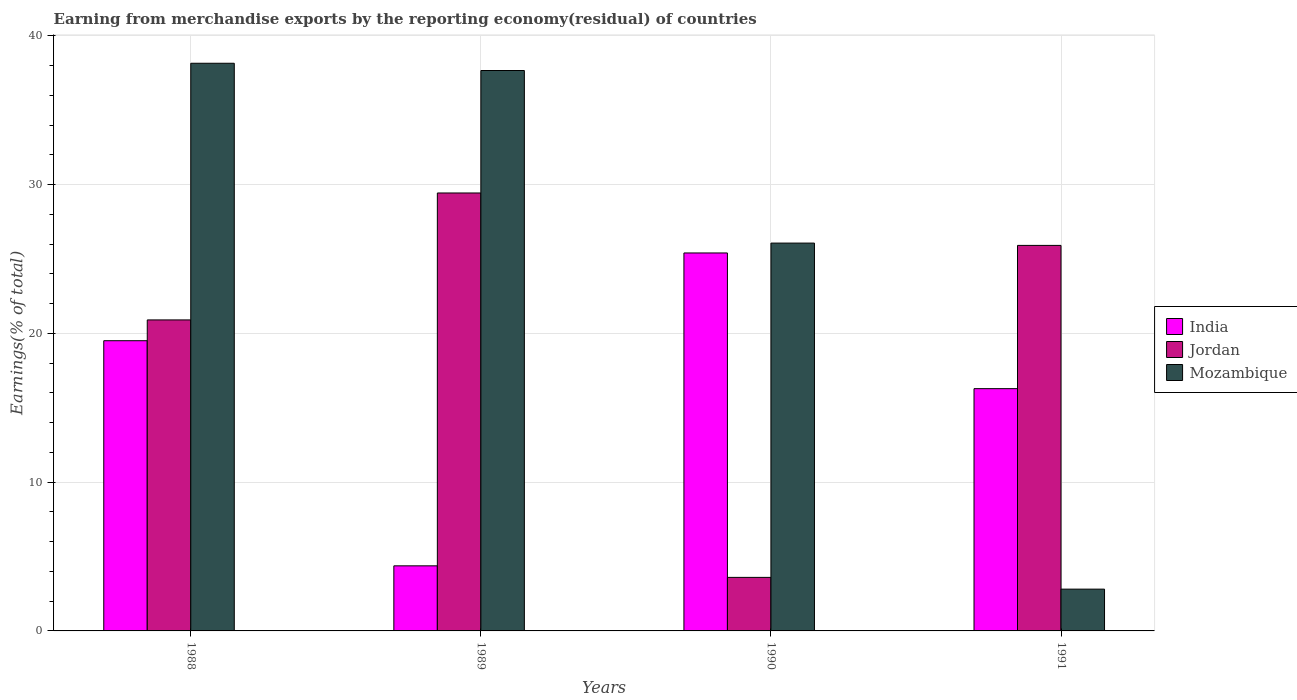How many groups of bars are there?
Ensure brevity in your answer.  4. What is the percentage of amount earned from merchandise exports in Jordan in 1988?
Keep it short and to the point. 20.91. Across all years, what is the maximum percentage of amount earned from merchandise exports in Jordan?
Ensure brevity in your answer.  29.44. Across all years, what is the minimum percentage of amount earned from merchandise exports in Mozambique?
Give a very brief answer. 2.81. In which year was the percentage of amount earned from merchandise exports in Jordan maximum?
Offer a terse response. 1989. In which year was the percentage of amount earned from merchandise exports in Jordan minimum?
Provide a short and direct response. 1990. What is the total percentage of amount earned from merchandise exports in India in the graph?
Make the answer very short. 65.57. What is the difference between the percentage of amount earned from merchandise exports in Jordan in 1988 and that in 1990?
Keep it short and to the point. 17.31. What is the difference between the percentage of amount earned from merchandise exports in Mozambique in 1988 and the percentage of amount earned from merchandise exports in Jordan in 1989?
Your answer should be compact. 8.72. What is the average percentage of amount earned from merchandise exports in India per year?
Your response must be concise. 16.39. In the year 1991, what is the difference between the percentage of amount earned from merchandise exports in Mozambique and percentage of amount earned from merchandise exports in Jordan?
Your answer should be very brief. -23.11. In how many years, is the percentage of amount earned from merchandise exports in India greater than 16 %?
Provide a succinct answer. 3. What is the ratio of the percentage of amount earned from merchandise exports in Mozambique in 1989 to that in 1990?
Your answer should be very brief. 1.44. Is the percentage of amount earned from merchandise exports in Jordan in 1990 less than that in 1991?
Make the answer very short. Yes. Is the difference between the percentage of amount earned from merchandise exports in Mozambique in 1989 and 1990 greater than the difference between the percentage of amount earned from merchandise exports in Jordan in 1989 and 1990?
Your answer should be compact. No. What is the difference between the highest and the second highest percentage of amount earned from merchandise exports in Mozambique?
Make the answer very short. 0.49. What is the difference between the highest and the lowest percentage of amount earned from merchandise exports in Mozambique?
Provide a succinct answer. 35.35. Is the sum of the percentage of amount earned from merchandise exports in India in 1990 and 1991 greater than the maximum percentage of amount earned from merchandise exports in Jordan across all years?
Keep it short and to the point. Yes. What does the 3rd bar from the left in 1990 represents?
Your answer should be very brief. Mozambique. What does the 2nd bar from the right in 1991 represents?
Your answer should be very brief. Jordan. How many legend labels are there?
Make the answer very short. 3. What is the title of the graph?
Provide a short and direct response. Earning from merchandise exports by the reporting economy(residual) of countries. What is the label or title of the X-axis?
Provide a succinct answer. Years. What is the label or title of the Y-axis?
Keep it short and to the point. Earnings(% of total). What is the Earnings(% of total) in India in 1988?
Make the answer very short. 19.51. What is the Earnings(% of total) of Jordan in 1988?
Offer a terse response. 20.91. What is the Earnings(% of total) in Mozambique in 1988?
Your answer should be very brief. 38.16. What is the Earnings(% of total) in India in 1989?
Keep it short and to the point. 4.37. What is the Earnings(% of total) of Jordan in 1989?
Offer a very short reply. 29.44. What is the Earnings(% of total) of Mozambique in 1989?
Your answer should be very brief. 37.67. What is the Earnings(% of total) of India in 1990?
Ensure brevity in your answer.  25.41. What is the Earnings(% of total) of Jordan in 1990?
Your response must be concise. 3.6. What is the Earnings(% of total) in Mozambique in 1990?
Provide a short and direct response. 26.07. What is the Earnings(% of total) of India in 1991?
Provide a short and direct response. 16.28. What is the Earnings(% of total) in Jordan in 1991?
Offer a very short reply. 25.91. What is the Earnings(% of total) of Mozambique in 1991?
Ensure brevity in your answer.  2.81. Across all years, what is the maximum Earnings(% of total) in India?
Your response must be concise. 25.41. Across all years, what is the maximum Earnings(% of total) of Jordan?
Offer a very short reply. 29.44. Across all years, what is the maximum Earnings(% of total) in Mozambique?
Give a very brief answer. 38.16. Across all years, what is the minimum Earnings(% of total) in India?
Give a very brief answer. 4.37. Across all years, what is the minimum Earnings(% of total) in Jordan?
Ensure brevity in your answer.  3.6. Across all years, what is the minimum Earnings(% of total) of Mozambique?
Provide a short and direct response. 2.81. What is the total Earnings(% of total) of India in the graph?
Provide a short and direct response. 65.57. What is the total Earnings(% of total) of Jordan in the graph?
Provide a short and direct response. 79.86. What is the total Earnings(% of total) of Mozambique in the graph?
Keep it short and to the point. 104.71. What is the difference between the Earnings(% of total) in India in 1988 and that in 1989?
Your response must be concise. 15.13. What is the difference between the Earnings(% of total) of Jordan in 1988 and that in 1989?
Provide a succinct answer. -8.53. What is the difference between the Earnings(% of total) in Mozambique in 1988 and that in 1989?
Give a very brief answer. 0.49. What is the difference between the Earnings(% of total) of India in 1988 and that in 1990?
Provide a succinct answer. -5.9. What is the difference between the Earnings(% of total) of Jordan in 1988 and that in 1990?
Give a very brief answer. 17.31. What is the difference between the Earnings(% of total) of Mozambique in 1988 and that in 1990?
Keep it short and to the point. 12.09. What is the difference between the Earnings(% of total) in India in 1988 and that in 1991?
Your answer should be compact. 3.22. What is the difference between the Earnings(% of total) of Jordan in 1988 and that in 1991?
Make the answer very short. -5.01. What is the difference between the Earnings(% of total) in Mozambique in 1988 and that in 1991?
Offer a very short reply. 35.35. What is the difference between the Earnings(% of total) in India in 1989 and that in 1990?
Provide a short and direct response. -21.03. What is the difference between the Earnings(% of total) of Jordan in 1989 and that in 1990?
Your response must be concise. 25.84. What is the difference between the Earnings(% of total) in Mozambique in 1989 and that in 1990?
Ensure brevity in your answer.  11.6. What is the difference between the Earnings(% of total) of India in 1989 and that in 1991?
Offer a terse response. -11.91. What is the difference between the Earnings(% of total) in Jordan in 1989 and that in 1991?
Offer a terse response. 3.52. What is the difference between the Earnings(% of total) in Mozambique in 1989 and that in 1991?
Your answer should be compact. 34.86. What is the difference between the Earnings(% of total) in India in 1990 and that in 1991?
Your answer should be compact. 9.12. What is the difference between the Earnings(% of total) in Jordan in 1990 and that in 1991?
Your answer should be compact. -22.32. What is the difference between the Earnings(% of total) of Mozambique in 1990 and that in 1991?
Ensure brevity in your answer.  23.26. What is the difference between the Earnings(% of total) of India in 1988 and the Earnings(% of total) of Jordan in 1989?
Provide a succinct answer. -9.93. What is the difference between the Earnings(% of total) of India in 1988 and the Earnings(% of total) of Mozambique in 1989?
Provide a succinct answer. -18.16. What is the difference between the Earnings(% of total) in Jordan in 1988 and the Earnings(% of total) in Mozambique in 1989?
Keep it short and to the point. -16.77. What is the difference between the Earnings(% of total) of India in 1988 and the Earnings(% of total) of Jordan in 1990?
Ensure brevity in your answer.  15.91. What is the difference between the Earnings(% of total) in India in 1988 and the Earnings(% of total) in Mozambique in 1990?
Provide a short and direct response. -6.56. What is the difference between the Earnings(% of total) in Jordan in 1988 and the Earnings(% of total) in Mozambique in 1990?
Offer a very short reply. -5.16. What is the difference between the Earnings(% of total) of India in 1988 and the Earnings(% of total) of Jordan in 1991?
Your answer should be compact. -6.41. What is the difference between the Earnings(% of total) of India in 1988 and the Earnings(% of total) of Mozambique in 1991?
Your answer should be compact. 16.7. What is the difference between the Earnings(% of total) in Jordan in 1988 and the Earnings(% of total) in Mozambique in 1991?
Provide a succinct answer. 18.1. What is the difference between the Earnings(% of total) in India in 1989 and the Earnings(% of total) in Jordan in 1990?
Give a very brief answer. 0.78. What is the difference between the Earnings(% of total) of India in 1989 and the Earnings(% of total) of Mozambique in 1990?
Offer a very short reply. -21.69. What is the difference between the Earnings(% of total) in Jordan in 1989 and the Earnings(% of total) in Mozambique in 1990?
Ensure brevity in your answer.  3.37. What is the difference between the Earnings(% of total) in India in 1989 and the Earnings(% of total) in Jordan in 1991?
Your answer should be compact. -21.54. What is the difference between the Earnings(% of total) of India in 1989 and the Earnings(% of total) of Mozambique in 1991?
Ensure brevity in your answer.  1.57. What is the difference between the Earnings(% of total) of Jordan in 1989 and the Earnings(% of total) of Mozambique in 1991?
Your answer should be compact. 26.63. What is the difference between the Earnings(% of total) of India in 1990 and the Earnings(% of total) of Jordan in 1991?
Your answer should be compact. -0.51. What is the difference between the Earnings(% of total) in India in 1990 and the Earnings(% of total) in Mozambique in 1991?
Make the answer very short. 22.6. What is the difference between the Earnings(% of total) in Jordan in 1990 and the Earnings(% of total) in Mozambique in 1991?
Your response must be concise. 0.79. What is the average Earnings(% of total) of India per year?
Provide a succinct answer. 16.39. What is the average Earnings(% of total) in Jordan per year?
Make the answer very short. 19.96. What is the average Earnings(% of total) of Mozambique per year?
Offer a very short reply. 26.18. In the year 1988, what is the difference between the Earnings(% of total) in India and Earnings(% of total) in Jordan?
Make the answer very short. -1.4. In the year 1988, what is the difference between the Earnings(% of total) of India and Earnings(% of total) of Mozambique?
Offer a terse response. -18.65. In the year 1988, what is the difference between the Earnings(% of total) of Jordan and Earnings(% of total) of Mozambique?
Keep it short and to the point. -17.25. In the year 1989, what is the difference between the Earnings(% of total) in India and Earnings(% of total) in Jordan?
Ensure brevity in your answer.  -25.06. In the year 1989, what is the difference between the Earnings(% of total) in India and Earnings(% of total) in Mozambique?
Your answer should be very brief. -33.3. In the year 1989, what is the difference between the Earnings(% of total) in Jordan and Earnings(% of total) in Mozambique?
Offer a very short reply. -8.23. In the year 1990, what is the difference between the Earnings(% of total) in India and Earnings(% of total) in Jordan?
Offer a very short reply. 21.81. In the year 1990, what is the difference between the Earnings(% of total) of India and Earnings(% of total) of Mozambique?
Your answer should be compact. -0.66. In the year 1990, what is the difference between the Earnings(% of total) of Jordan and Earnings(% of total) of Mozambique?
Give a very brief answer. -22.47. In the year 1991, what is the difference between the Earnings(% of total) of India and Earnings(% of total) of Jordan?
Offer a terse response. -9.63. In the year 1991, what is the difference between the Earnings(% of total) of India and Earnings(% of total) of Mozambique?
Provide a short and direct response. 13.48. In the year 1991, what is the difference between the Earnings(% of total) of Jordan and Earnings(% of total) of Mozambique?
Offer a very short reply. 23.11. What is the ratio of the Earnings(% of total) of India in 1988 to that in 1989?
Keep it short and to the point. 4.46. What is the ratio of the Earnings(% of total) in Jordan in 1988 to that in 1989?
Your answer should be compact. 0.71. What is the ratio of the Earnings(% of total) of Mozambique in 1988 to that in 1989?
Make the answer very short. 1.01. What is the ratio of the Earnings(% of total) in India in 1988 to that in 1990?
Provide a succinct answer. 0.77. What is the ratio of the Earnings(% of total) of Jordan in 1988 to that in 1990?
Keep it short and to the point. 5.81. What is the ratio of the Earnings(% of total) in Mozambique in 1988 to that in 1990?
Your answer should be compact. 1.46. What is the ratio of the Earnings(% of total) of India in 1988 to that in 1991?
Make the answer very short. 1.2. What is the ratio of the Earnings(% of total) in Jordan in 1988 to that in 1991?
Keep it short and to the point. 0.81. What is the ratio of the Earnings(% of total) of Mozambique in 1988 to that in 1991?
Offer a very short reply. 13.58. What is the ratio of the Earnings(% of total) of India in 1989 to that in 1990?
Your answer should be compact. 0.17. What is the ratio of the Earnings(% of total) in Jordan in 1989 to that in 1990?
Your response must be concise. 8.18. What is the ratio of the Earnings(% of total) in Mozambique in 1989 to that in 1990?
Provide a succinct answer. 1.45. What is the ratio of the Earnings(% of total) of India in 1989 to that in 1991?
Keep it short and to the point. 0.27. What is the ratio of the Earnings(% of total) of Jordan in 1989 to that in 1991?
Offer a terse response. 1.14. What is the ratio of the Earnings(% of total) of Mozambique in 1989 to that in 1991?
Your answer should be compact. 13.41. What is the ratio of the Earnings(% of total) of India in 1990 to that in 1991?
Give a very brief answer. 1.56. What is the ratio of the Earnings(% of total) of Jordan in 1990 to that in 1991?
Provide a succinct answer. 0.14. What is the ratio of the Earnings(% of total) of Mozambique in 1990 to that in 1991?
Your answer should be very brief. 9.28. What is the difference between the highest and the second highest Earnings(% of total) of India?
Provide a short and direct response. 5.9. What is the difference between the highest and the second highest Earnings(% of total) in Jordan?
Ensure brevity in your answer.  3.52. What is the difference between the highest and the second highest Earnings(% of total) in Mozambique?
Provide a succinct answer. 0.49. What is the difference between the highest and the lowest Earnings(% of total) in India?
Provide a short and direct response. 21.03. What is the difference between the highest and the lowest Earnings(% of total) in Jordan?
Provide a succinct answer. 25.84. What is the difference between the highest and the lowest Earnings(% of total) of Mozambique?
Offer a very short reply. 35.35. 